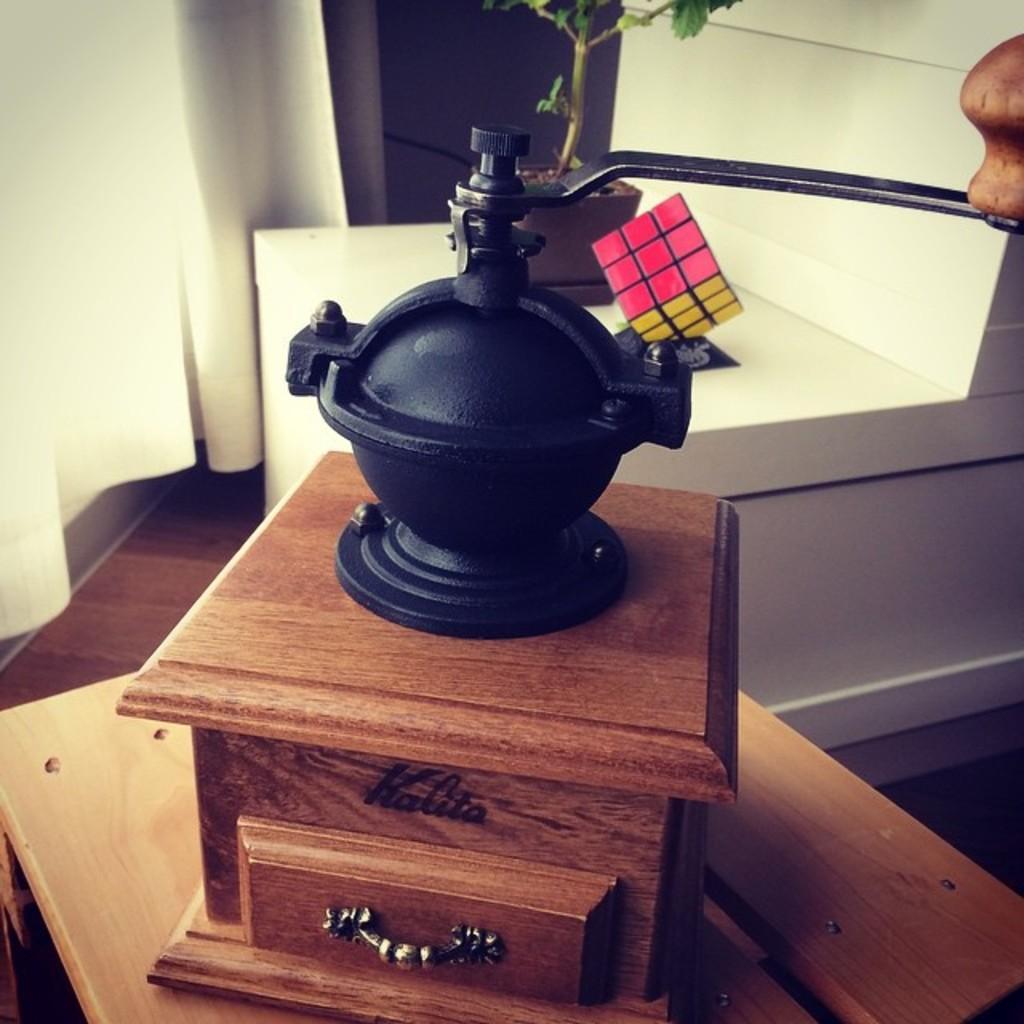Can you describe this image briefly? This Picture describe as it look like old musical instrument gramophone, behind we can see small decor plant and white curtain. This wooden instrument is placed on the table and handle on the top right side. 